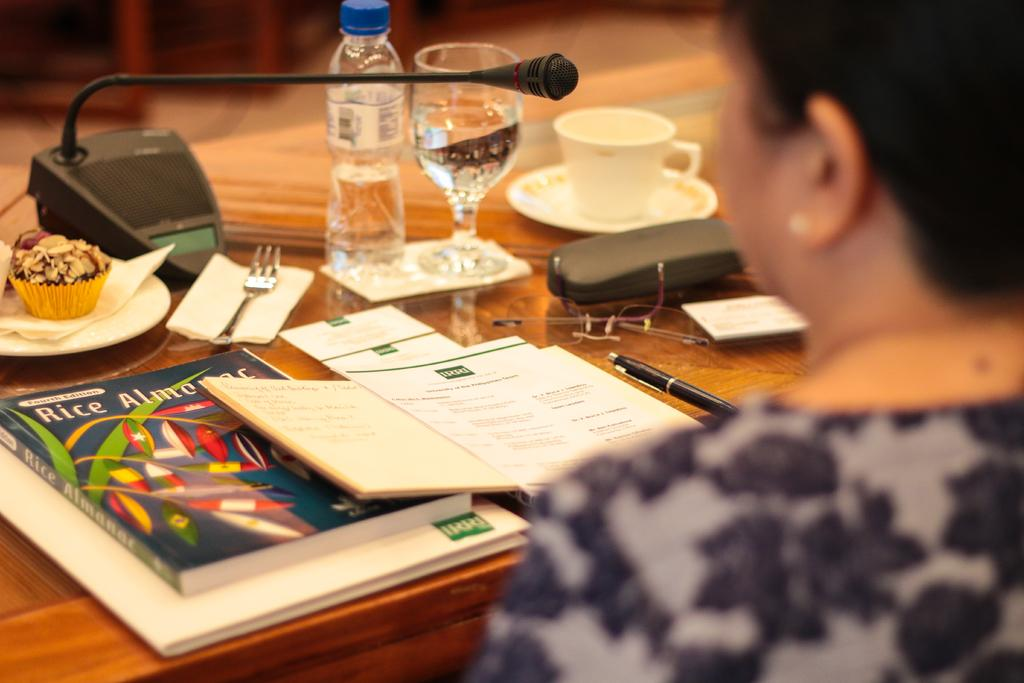<image>
Provide a brief description of the given image. A Rice Almanac is sitting on a table with a water bottle and a cupcake. 